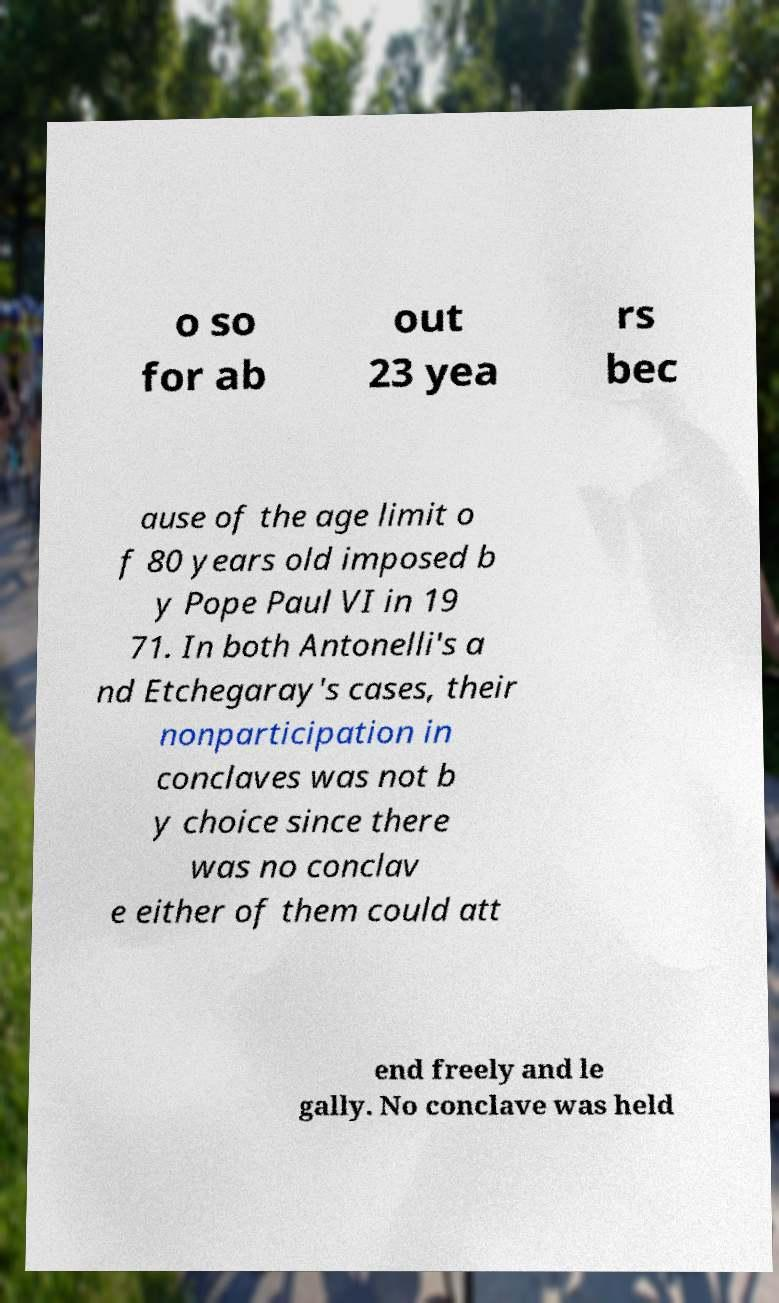Please identify and transcribe the text found in this image. o so for ab out 23 yea rs bec ause of the age limit o f 80 years old imposed b y Pope Paul VI in 19 71. In both Antonelli's a nd Etchegaray's cases, their nonparticipation in conclaves was not b y choice since there was no conclav e either of them could att end freely and le gally. No conclave was held 